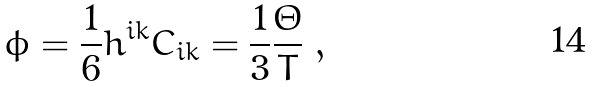Convert formula to latex. <formula><loc_0><loc_0><loc_500><loc_500>\phi = \frac { 1 } { 6 } h ^ { i k } C _ { i k } = \frac { 1 } { 3 } \frac { \Theta } { T } \ ,</formula> 